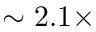Convert formula to latex. <formula><loc_0><loc_0><loc_500><loc_500>\sim 2 . 1 \times</formula> 